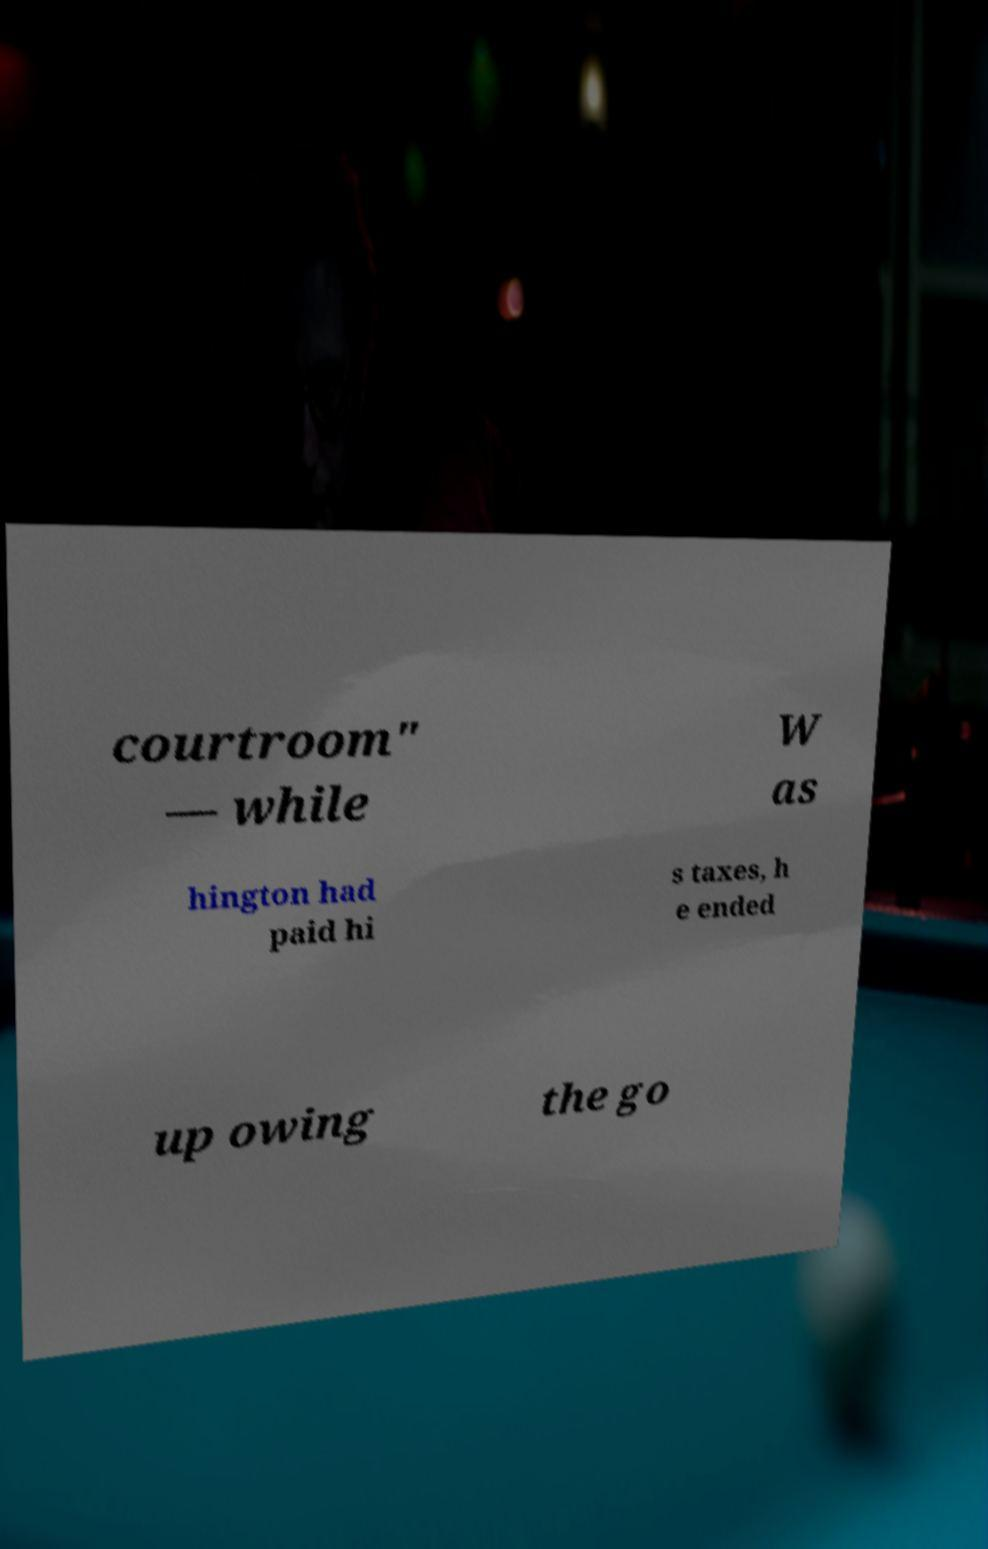For documentation purposes, I need the text within this image transcribed. Could you provide that? courtroom" — while W as hington had paid hi s taxes, h e ended up owing the go 